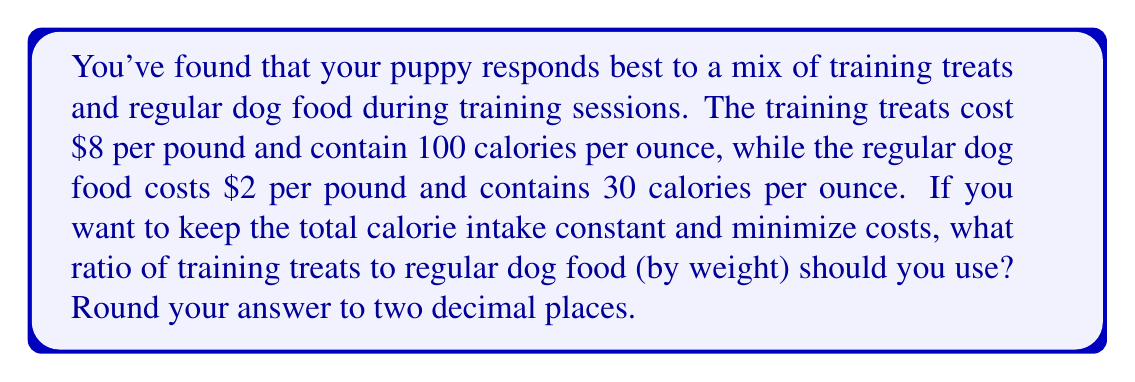Could you help me with this problem? Let's approach this step-by-step:

1) First, let's define our variables:
   $x$ = weight of training treats in ounces
   $y$ = weight of regular dog food in ounces

2) We need to express the cost in terms of $x$ and $y$:
   Cost = $\frac{8}{16}x + \frac{2}{16}y = 0.5x + 0.125y$

3) Now, let's express the calorie content:
   Calories = $100x + 30y$

4) We want to keep the calorie content constant, so let's set it to $C$:
   $100x + 30y = C$

5) We can express $y$ in terms of $x$:
   $y = \frac{C - 100x}{30}$

6) Substituting this into our cost equation:
   Cost = $0.5x + 0.125(\frac{C - 100x}{30})$
        = $0.5x + \frac{0.125C}{30} - \frac{12.5x}{30}$
        = $0.5x + \frac{0.125C}{30} - 0.4167x$
        = $0.0833x + \frac{0.125C}{30}$

7) To minimize cost, we want to minimize $x$ (since the coefficient is positive). 
   However, we can't make $x = 0$ as we need some training treats.

8) Let's say we want 10% of the calories to come from treats:
   $100x = 0.1C$
   $x = 0.001C$

9) Substituting this back into our equation for $y$:
   $y = \frac{C - 100(0.001C)}{30} = \frac{0.9C}{30} = 0.03C$

10) The ratio of treats to regular food is:
    $\frac{x}{y} = \frac{0.001C}{0.03C} = \frac{1}{30} \approx 0.03$
Answer: 1:30 or 0.03 